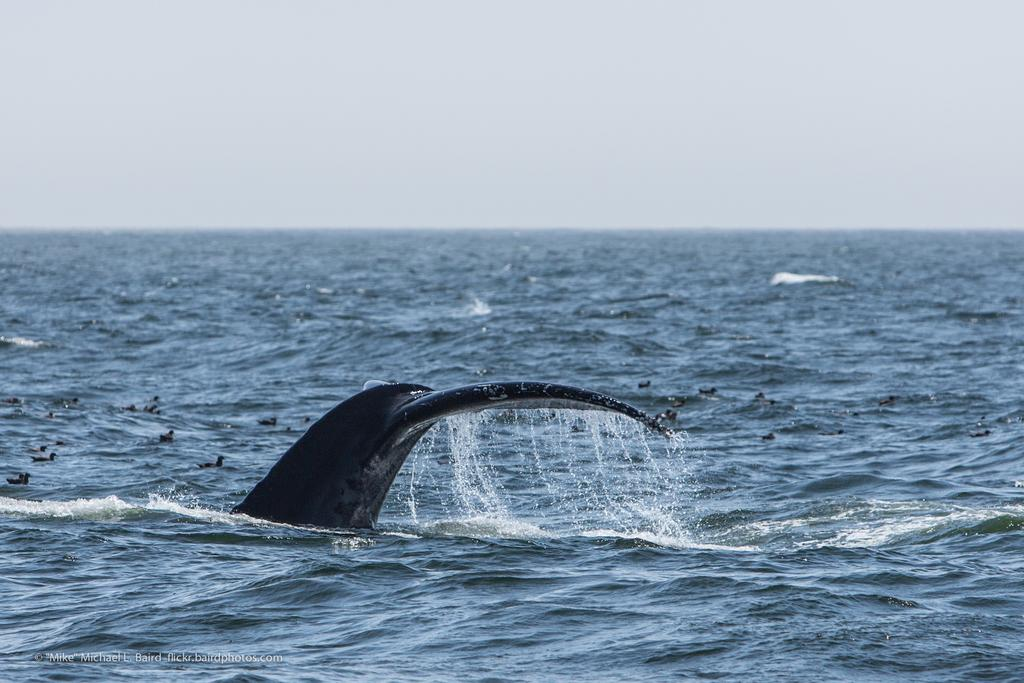What animals can be seen in the water in the image? There are dolphins and ducks swimming in the water in the image. What part of the natural environment is visible in the image? The sky is visible in the image. What type of war is depicted in the image? There is no depiction of war in the image; it features dolphins, ducks, and the sky. What vase can be seen in the image? There is no vase present in the image. 